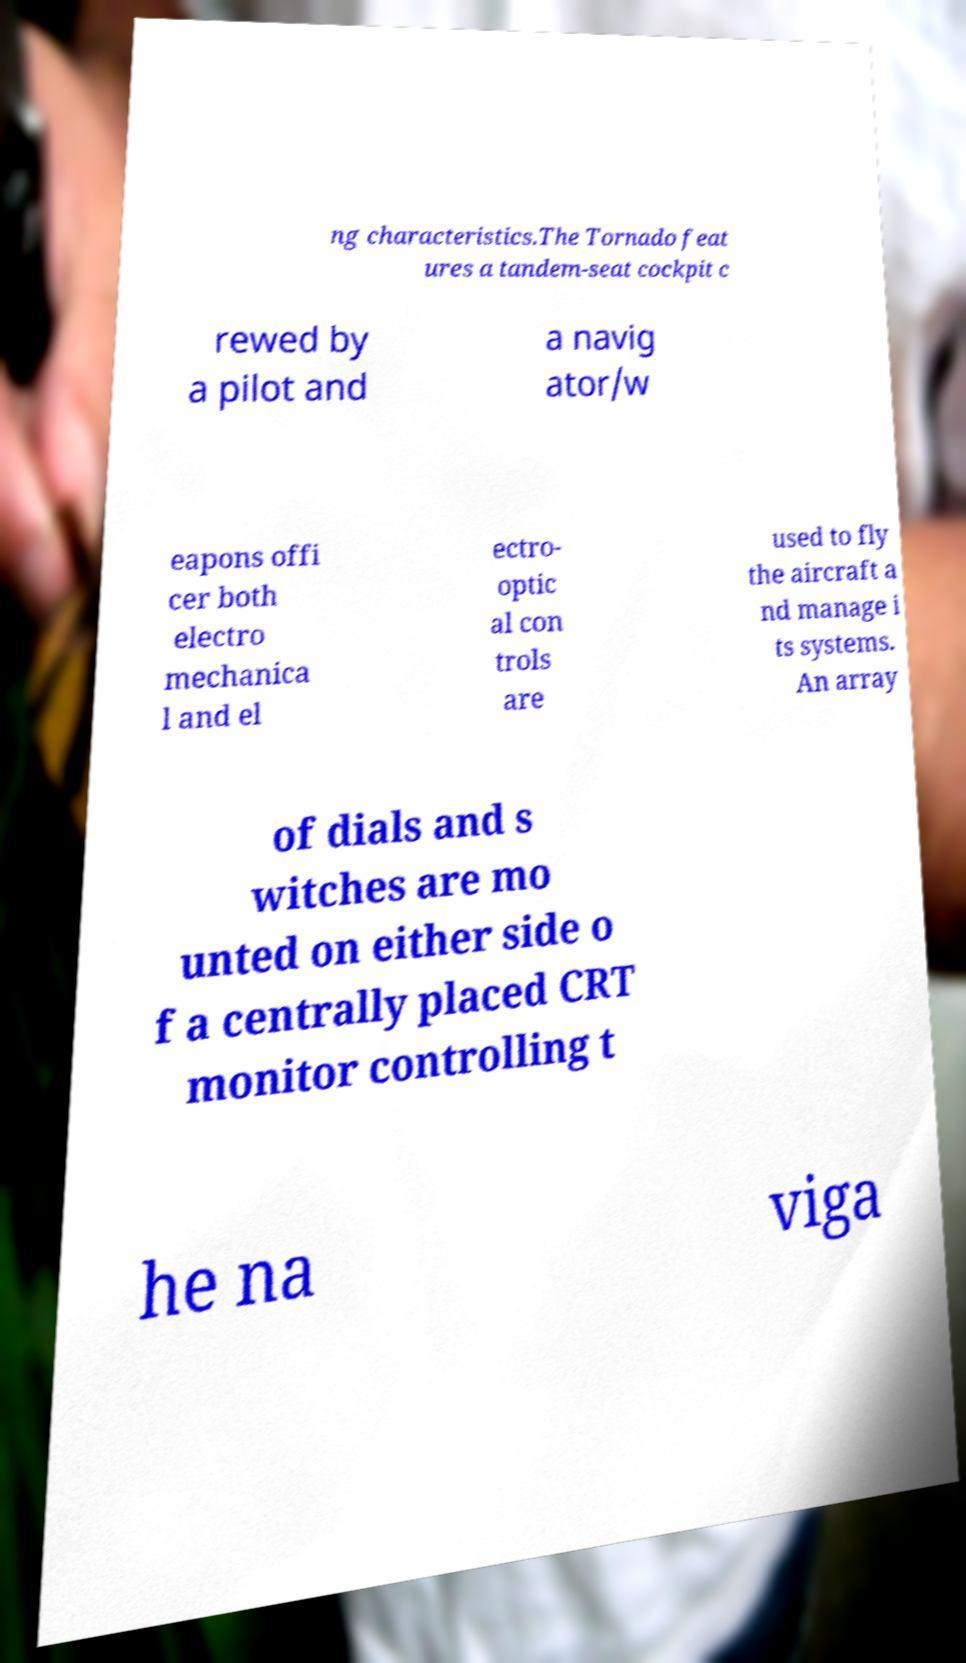What messages or text are displayed in this image? I need them in a readable, typed format. ng characteristics.The Tornado feat ures a tandem-seat cockpit c rewed by a pilot and a navig ator/w eapons offi cer both electro mechanica l and el ectro- optic al con trols are used to fly the aircraft a nd manage i ts systems. An array of dials and s witches are mo unted on either side o f a centrally placed CRT monitor controlling t he na viga 